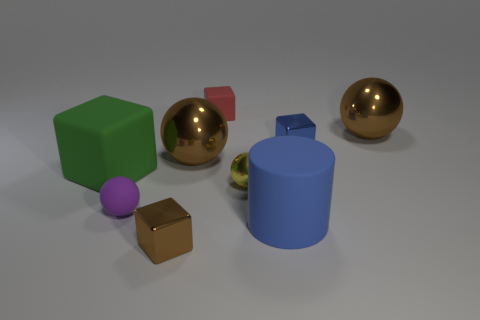There is a small cube that is in front of the tiny red object and behind the large rubber block; what is its color?
Offer a very short reply. Blue. What size is the brown metal block?
Your answer should be very brief. Small. What number of balls have the same size as the blue shiny thing?
Make the answer very short. 2. Do the object that is to the right of the small blue cube and the cube that is in front of the big green matte thing have the same material?
Offer a very short reply. Yes. What is the tiny block that is to the left of the large brown shiny object that is in front of the blue metallic cube made of?
Offer a very short reply. Metal. What is the purple thing that is left of the yellow sphere made of?
Give a very brief answer. Rubber. What number of red matte things are the same shape as the big green thing?
Provide a succinct answer. 1. Does the tiny matte cube have the same color as the large cylinder?
Your answer should be very brief. No. There is a big brown sphere that is in front of the tiny metal cube on the right side of the large ball left of the tiny blue metal block; what is its material?
Keep it short and to the point. Metal. There is a large cylinder; are there any brown blocks on the right side of it?
Offer a very short reply. No. 